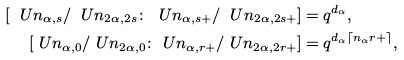<formula> <loc_0><loc_0><loc_500><loc_500>[ \ U n _ { \alpha , s } / \ U n _ { 2 \alpha , 2 s } \colon \ U n _ { \alpha , s { + } } / \ U n _ { 2 \alpha , 2 s { + } } ] & = q ^ { d _ { \alpha } } , \\ [ \ U n _ { \alpha , 0 } / \ U n _ { 2 \alpha , 0 } \colon \ U n _ { \alpha , r { + } } / \ U n _ { 2 \alpha , 2 r { + } } ] & = q ^ { d _ { \alpha } \lceil n _ { \alpha } r { + } \rceil } ,</formula> 